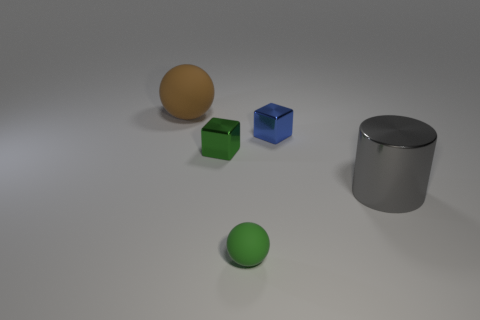Add 1 matte things. How many objects exist? 6 Subtract 1 cubes. How many cubes are left? 1 Subtract all green spheres. How many spheres are left? 1 Subtract all blocks. How many objects are left? 3 Subtract all brown spheres. Subtract all gray blocks. How many spheres are left? 1 Subtract all brown blocks. How many purple spheres are left? 0 Subtract all large cyan shiny balls. Subtract all gray things. How many objects are left? 4 Add 3 metallic blocks. How many metallic blocks are left? 5 Add 5 green rubber balls. How many green rubber balls exist? 6 Subtract 1 green cubes. How many objects are left? 4 